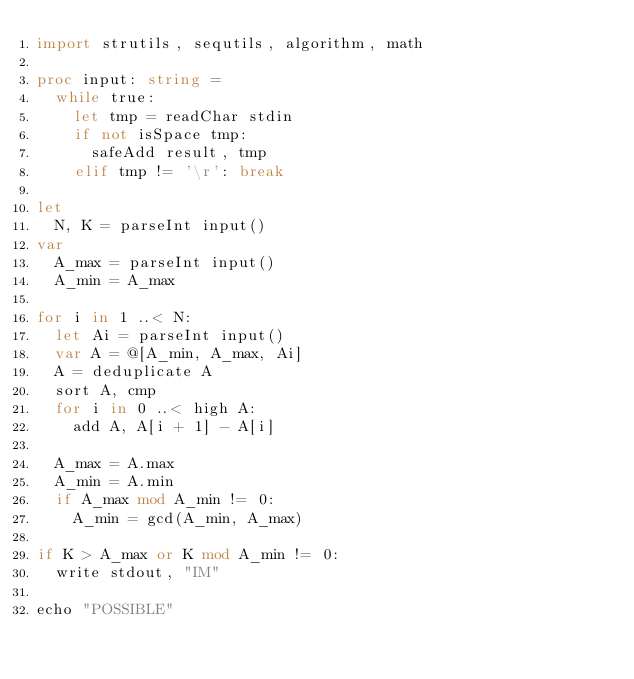Convert code to text. <code><loc_0><loc_0><loc_500><loc_500><_Nim_>import strutils, sequtils, algorithm, math

proc input: string =
  while true:
    let tmp = readChar stdin
    if not isSpace tmp:
      safeAdd result, tmp
    elif tmp != '\r': break

let
  N, K = parseInt input()
var
  A_max = parseInt input()
  A_min = A_max

for i in 1 ..< N:
  let Ai = parseInt input()
  var A = @[A_min, A_max, Ai]
  A = deduplicate A
  sort A, cmp
  for i in 0 ..< high A:
    add A, A[i + 1] - A[i]

  A_max = A.max
  A_min = A.min
  if A_max mod A_min != 0:
    A_min = gcd(A_min, A_max)

if K > A_max or K mod A_min != 0:
  write stdout, "IM"

echo "POSSIBLE"
</code> 